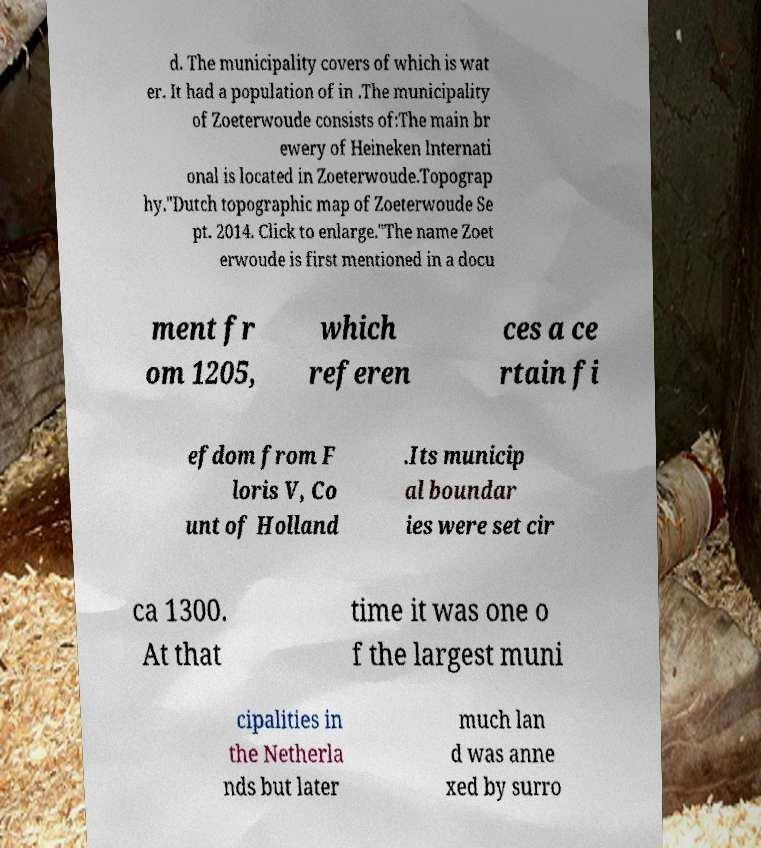For documentation purposes, I need the text within this image transcribed. Could you provide that? d. The municipality covers of which is wat er. It had a population of in .The municipality of Zoeterwoude consists of:The main br ewery of Heineken Internati onal is located in Zoeterwoude.Topograp hy."Dutch topographic map of Zoeterwoude Se pt. 2014. Click to enlarge."The name Zoet erwoude is first mentioned in a docu ment fr om 1205, which referen ces a ce rtain fi efdom from F loris V, Co unt of Holland .Its municip al boundar ies were set cir ca 1300. At that time it was one o f the largest muni cipalities in the Netherla nds but later much lan d was anne xed by surro 